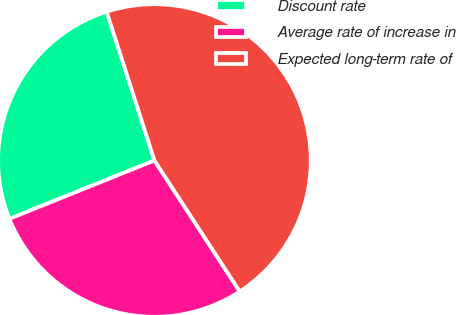Convert chart to OTSL. <chart><loc_0><loc_0><loc_500><loc_500><pie_chart><fcel>Discount rate<fcel>Average rate of increase in<fcel>Expected long-term rate of<nl><fcel>26.14%<fcel>28.1%<fcel>45.75%<nl></chart> 